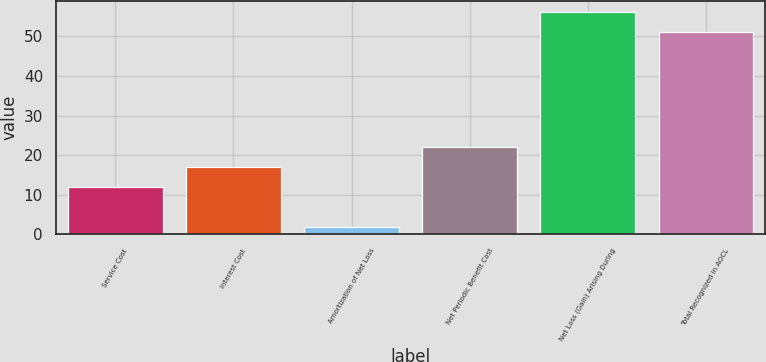Convert chart to OTSL. <chart><loc_0><loc_0><loc_500><loc_500><bar_chart><fcel>Service Cost<fcel>Interest Cost<fcel>Amortization of Net Loss<fcel>Net Periodic Benefit Cost<fcel>Net Loss (Gain) Arising During<fcel>Total Recognized in AOCL<nl><fcel>12<fcel>17.1<fcel>2<fcel>22.2<fcel>56.1<fcel>51<nl></chart> 